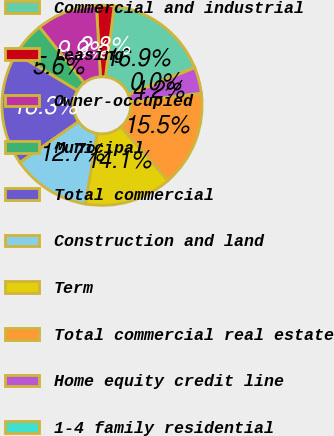<chart> <loc_0><loc_0><loc_500><loc_500><pie_chart><fcel>Commercial and industrial<fcel>Leasing<fcel>Owner-occupied<fcel>Municipal<fcel>Total commercial<fcel>Construction and land<fcel>Term<fcel>Total commercial real estate<fcel>Home equity credit line<fcel>1-4 family residential<nl><fcel>16.89%<fcel>2.82%<fcel>9.86%<fcel>5.64%<fcel>18.3%<fcel>12.67%<fcel>14.08%<fcel>15.49%<fcel>4.23%<fcel>0.01%<nl></chart> 